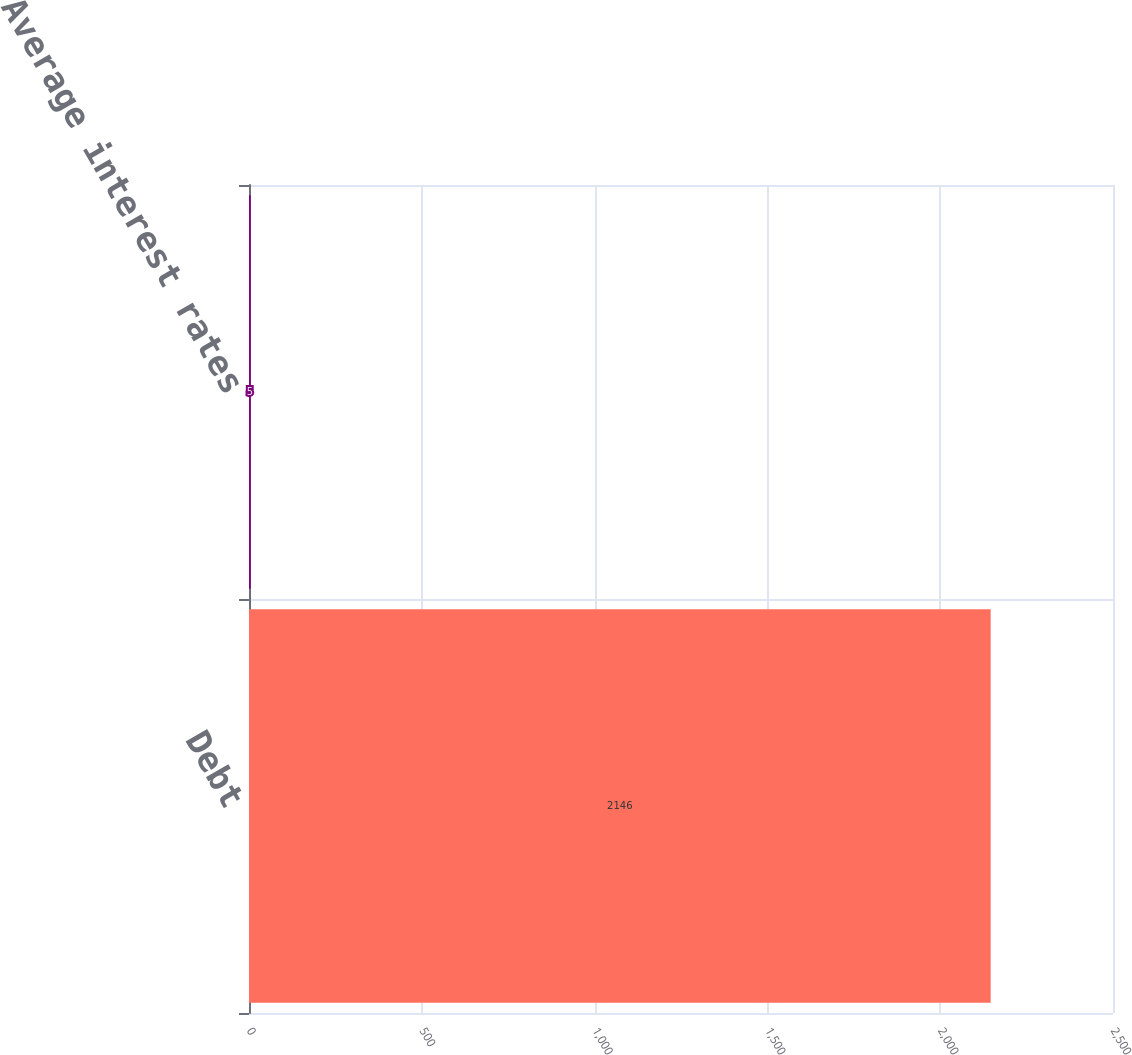<chart> <loc_0><loc_0><loc_500><loc_500><bar_chart><fcel>Debt<fcel>Average interest rates<nl><fcel>2146<fcel>5<nl></chart> 